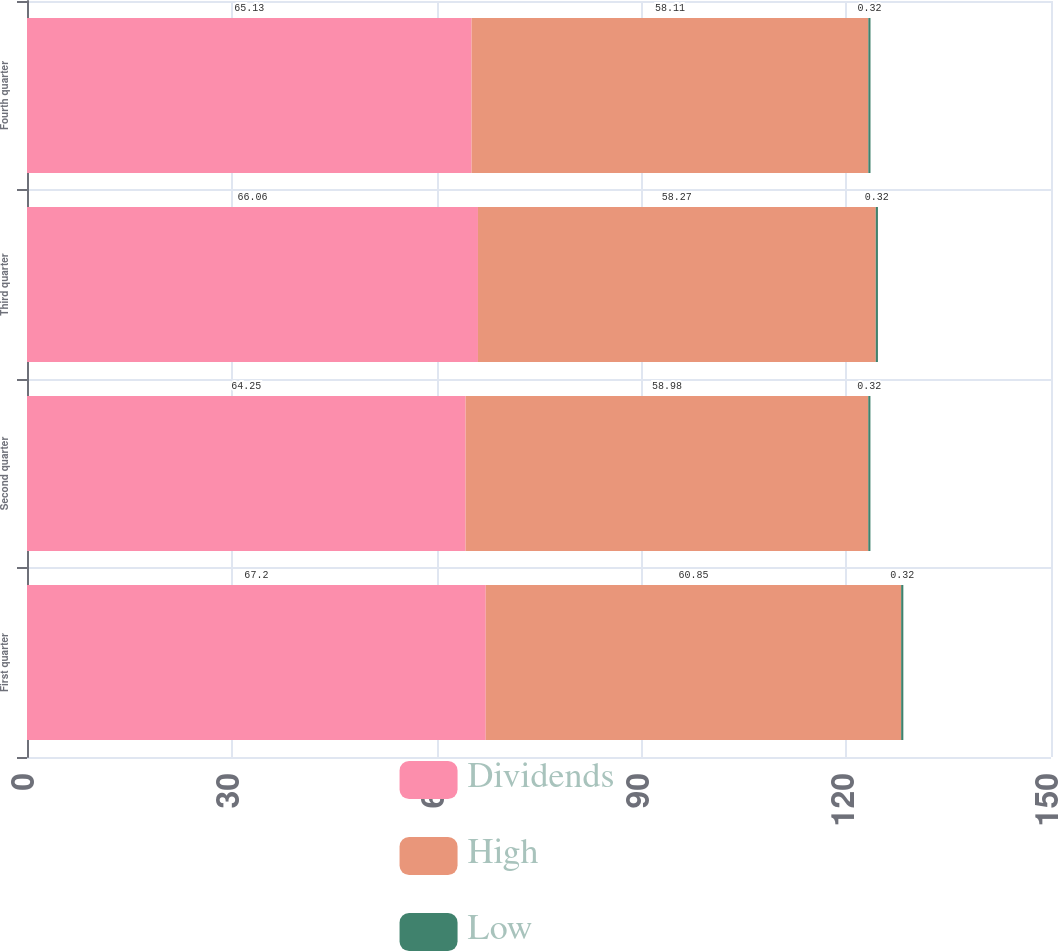Convert chart to OTSL. <chart><loc_0><loc_0><loc_500><loc_500><stacked_bar_chart><ecel><fcel>First quarter<fcel>Second quarter<fcel>Third quarter<fcel>Fourth quarter<nl><fcel>Dividends<fcel>67.2<fcel>64.25<fcel>66.06<fcel>65.13<nl><fcel>High<fcel>60.85<fcel>58.98<fcel>58.27<fcel>58.11<nl><fcel>Low<fcel>0.32<fcel>0.32<fcel>0.32<fcel>0.32<nl></chart> 